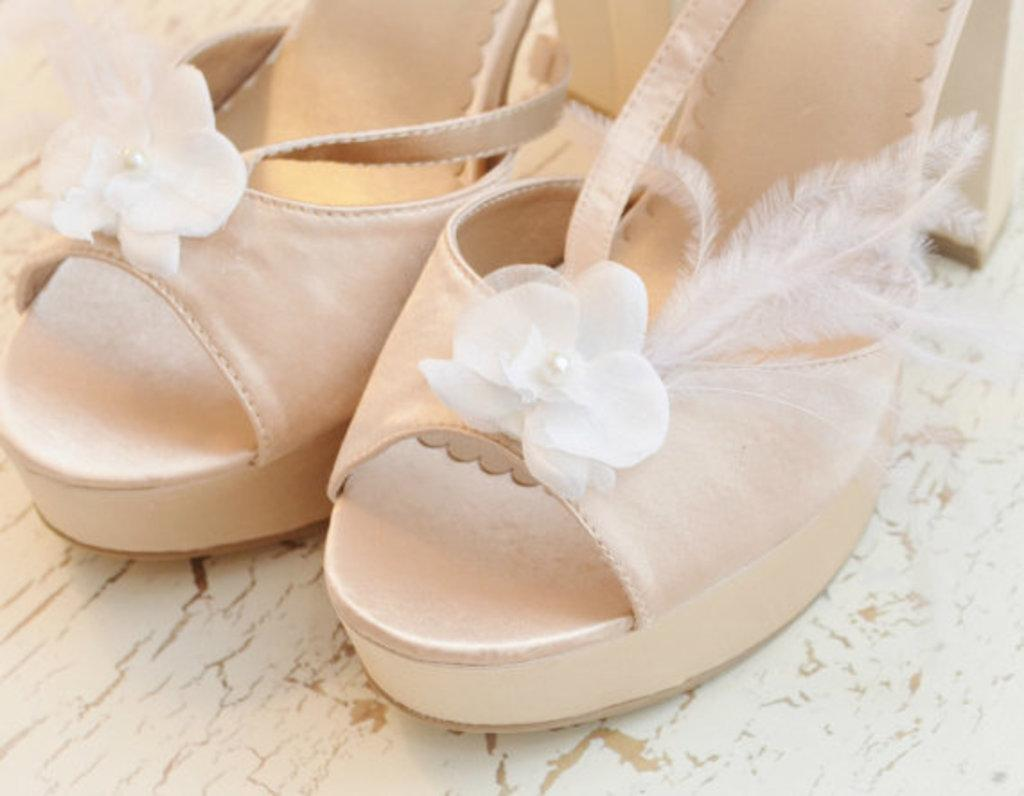What is the color of the surface in the image? The surface in the image is white and brown in color. What can be seen on the surface? There is a pair of footwear on the surface. What is the color of the footwear? The footwear is cream and white in color. Can you see any ants crawling on the grass in the image? There is no grass or ants present in the image; it features a white and brown surface with a pair of cream and white footwear. 